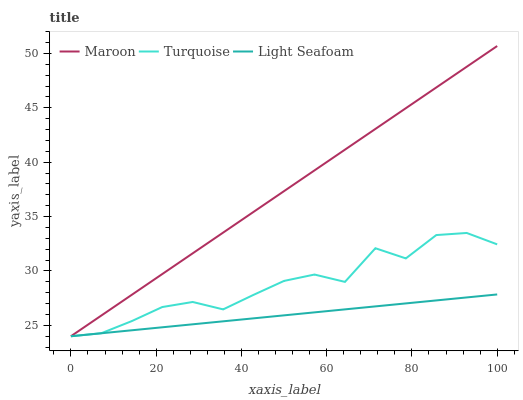Does Maroon have the minimum area under the curve?
Answer yes or no. No. Does Light Seafoam have the maximum area under the curve?
Answer yes or no. No. Is Maroon the smoothest?
Answer yes or no. No. Is Maroon the roughest?
Answer yes or no. No. Does Light Seafoam have the highest value?
Answer yes or no. No. 